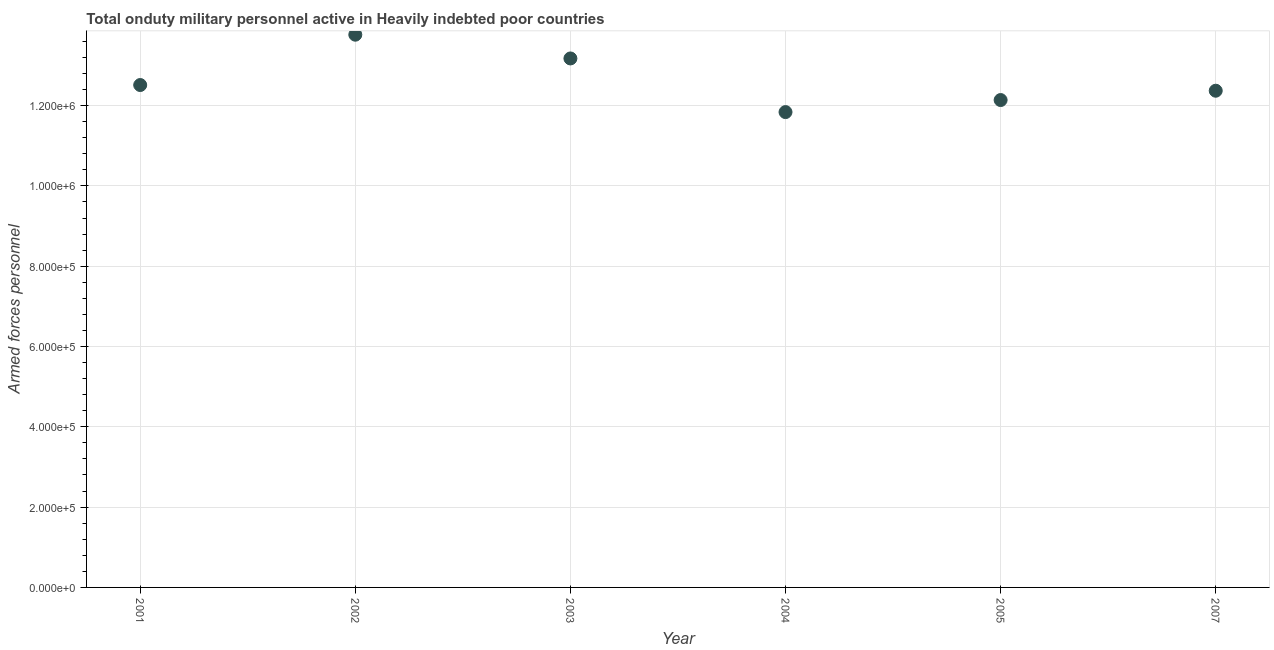What is the number of armed forces personnel in 2003?
Your answer should be very brief. 1.32e+06. Across all years, what is the maximum number of armed forces personnel?
Make the answer very short. 1.38e+06. Across all years, what is the minimum number of armed forces personnel?
Offer a very short reply. 1.18e+06. In which year was the number of armed forces personnel minimum?
Your answer should be very brief. 2004. What is the sum of the number of armed forces personnel?
Provide a short and direct response. 7.58e+06. What is the difference between the number of armed forces personnel in 2005 and 2007?
Keep it short and to the point. -2.32e+04. What is the average number of armed forces personnel per year?
Offer a very short reply. 1.26e+06. What is the median number of armed forces personnel?
Provide a succinct answer. 1.24e+06. In how many years, is the number of armed forces personnel greater than 760000 ?
Your answer should be compact. 6. Do a majority of the years between 2002 and 2001 (inclusive) have number of armed forces personnel greater than 920000 ?
Your answer should be very brief. No. What is the ratio of the number of armed forces personnel in 2003 to that in 2007?
Make the answer very short. 1.06. Is the difference between the number of armed forces personnel in 2001 and 2003 greater than the difference between any two years?
Give a very brief answer. No. What is the difference between the highest and the second highest number of armed forces personnel?
Your response must be concise. 5.92e+04. Is the sum of the number of armed forces personnel in 2004 and 2005 greater than the maximum number of armed forces personnel across all years?
Make the answer very short. Yes. What is the difference between the highest and the lowest number of armed forces personnel?
Your response must be concise. 1.93e+05. In how many years, is the number of armed forces personnel greater than the average number of armed forces personnel taken over all years?
Your answer should be compact. 2. Does the number of armed forces personnel monotonically increase over the years?
Offer a terse response. No. How many dotlines are there?
Ensure brevity in your answer.  1. What is the difference between two consecutive major ticks on the Y-axis?
Ensure brevity in your answer.  2.00e+05. Are the values on the major ticks of Y-axis written in scientific E-notation?
Keep it short and to the point. Yes. Does the graph contain any zero values?
Provide a succinct answer. No. Does the graph contain grids?
Provide a short and direct response. Yes. What is the title of the graph?
Ensure brevity in your answer.  Total onduty military personnel active in Heavily indebted poor countries. What is the label or title of the Y-axis?
Offer a terse response. Armed forces personnel. What is the Armed forces personnel in 2001?
Provide a succinct answer. 1.25e+06. What is the Armed forces personnel in 2002?
Offer a terse response. 1.38e+06. What is the Armed forces personnel in 2003?
Your response must be concise. 1.32e+06. What is the Armed forces personnel in 2004?
Make the answer very short. 1.18e+06. What is the Armed forces personnel in 2005?
Provide a succinct answer. 1.21e+06. What is the Armed forces personnel in 2007?
Your response must be concise. 1.24e+06. What is the difference between the Armed forces personnel in 2001 and 2002?
Ensure brevity in your answer.  -1.25e+05. What is the difference between the Armed forces personnel in 2001 and 2003?
Provide a short and direct response. -6.62e+04. What is the difference between the Armed forces personnel in 2001 and 2004?
Keep it short and to the point. 6.74e+04. What is the difference between the Armed forces personnel in 2001 and 2005?
Your answer should be very brief. 3.74e+04. What is the difference between the Armed forces personnel in 2001 and 2007?
Provide a short and direct response. 1.42e+04. What is the difference between the Armed forces personnel in 2002 and 2003?
Ensure brevity in your answer.  5.92e+04. What is the difference between the Armed forces personnel in 2002 and 2004?
Provide a succinct answer. 1.93e+05. What is the difference between the Armed forces personnel in 2002 and 2005?
Make the answer very short. 1.63e+05. What is the difference between the Armed forces personnel in 2002 and 2007?
Give a very brief answer. 1.40e+05. What is the difference between the Armed forces personnel in 2003 and 2004?
Offer a terse response. 1.34e+05. What is the difference between the Armed forces personnel in 2003 and 2005?
Give a very brief answer. 1.04e+05. What is the difference between the Armed forces personnel in 2003 and 2007?
Make the answer very short. 8.04e+04. What is the difference between the Armed forces personnel in 2004 and 2005?
Offer a terse response. -3.00e+04. What is the difference between the Armed forces personnel in 2004 and 2007?
Offer a terse response. -5.32e+04. What is the difference between the Armed forces personnel in 2005 and 2007?
Provide a short and direct response. -2.32e+04. What is the ratio of the Armed forces personnel in 2001 to that in 2002?
Offer a terse response. 0.91. What is the ratio of the Armed forces personnel in 2001 to that in 2003?
Give a very brief answer. 0.95. What is the ratio of the Armed forces personnel in 2001 to that in 2004?
Offer a terse response. 1.06. What is the ratio of the Armed forces personnel in 2001 to that in 2005?
Your response must be concise. 1.03. What is the ratio of the Armed forces personnel in 2002 to that in 2003?
Your answer should be compact. 1.04. What is the ratio of the Armed forces personnel in 2002 to that in 2004?
Provide a short and direct response. 1.16. What is the ratio of the Armed forces personnel in 2002 to that in 2005?
Make the answer very short. 1.13. What is the ratio of the Armed forces personnel in 2002 to that in 2007?
Offer a very short reply. 1.11. What is the ratio of the Armed forces personnel in 2003 to that in 2004?
Ensure brevity in your answer.  1.11. What is the ratio of the Armed forces personnel in 2003 to that in 2005?
Give a very brief answer. 1.08. What is the ratio of the Armed forces personnel in 2003 to that in 2007?
Make the answer very short. 1.06. What is the ratio of the Armed forces personnel in 2004 to that in 2005?
Your response must be concise. 0.97. What is the ratio of the Armed forces personnel in 2004 to that in 2007?
Provide a short and direct response. 0.96. What is the ratio of the Armed forces personnel in 2005 to that in 2007?
Your response must be concise. 0.98. 